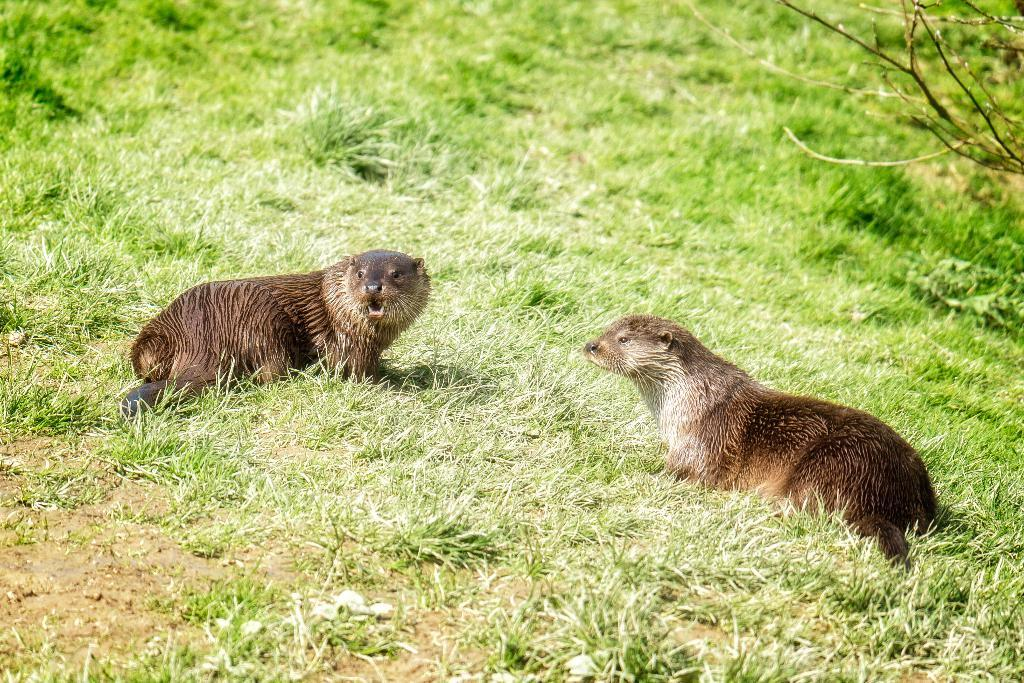What types of living organisms can be seen in the image? There are animals in the image. What type of vegetation is present in the image? There is grass in the image. What other natural elements can be seen in the image? There are branches in the image. What does the caption on the image say about the spiders near the stream? There is no caption, spiders, or stream present in the image. 